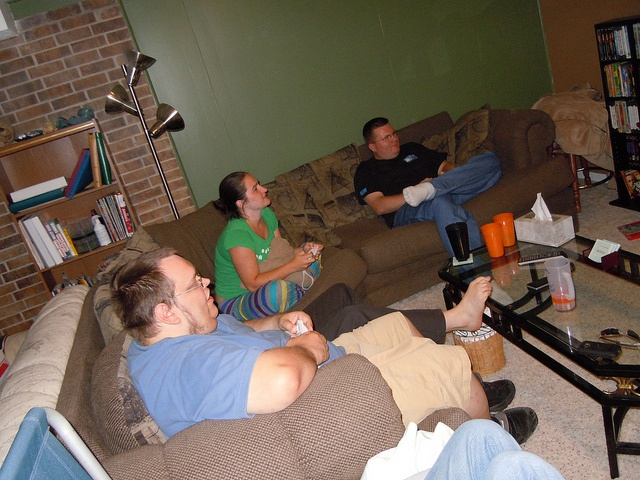Describe the objects in this image and their specific colors. I can see couch in gray, maroon, and black tones, dining table in gray, black, and darkgray tones, people in gray, darkgray, salmon, and tan tones, people in gray, black, darkblue, and maroon tones, and people in gray, brown, teal, and green tones in this image. 